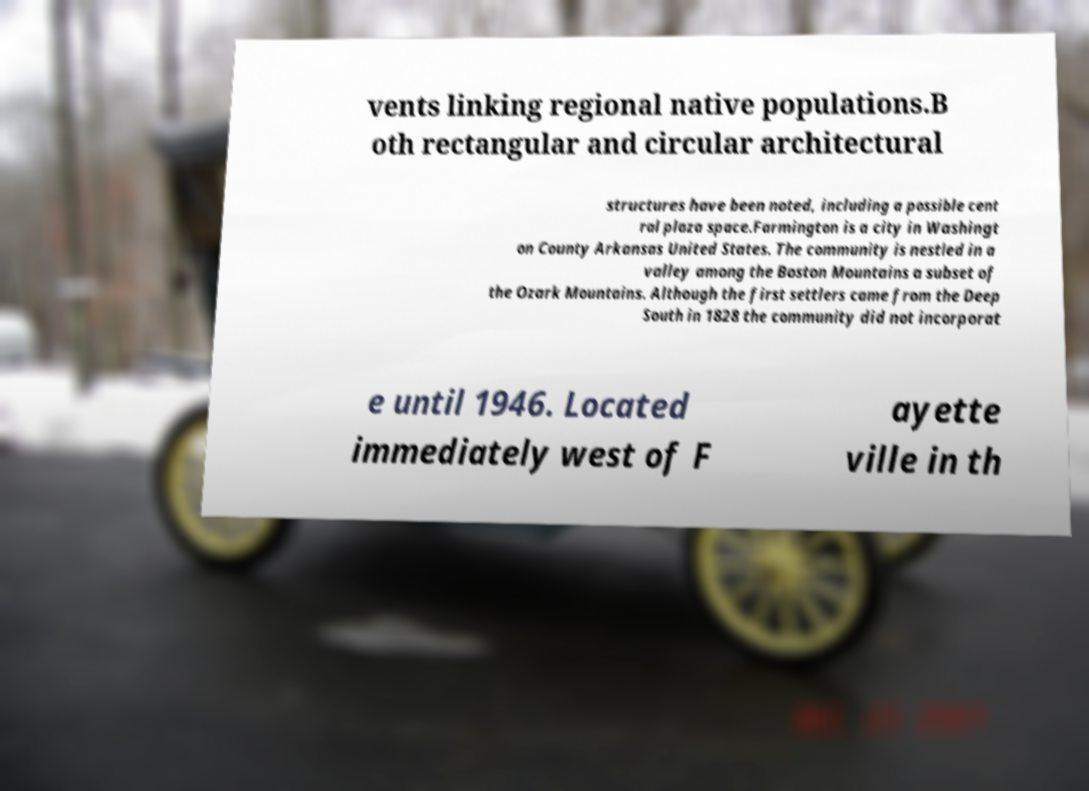Can you read and provide the text displayed in the image?This photo seems to have some interesting text. Can you extract and type it out for me? vents linking regional native populations.B oth rectangular and circular architectural structures have been noted, including a possible cent ral plaza space.Farmington is a city in Washingt on County Arkansas United States. The community is nestled in a valley among the Boston Mountains a subset of the Ozark Mountains. Although the first settlers came from the Deep South in 1828 the community did not incorporat e until 1946. Located immediately west of F ayette ville in th 